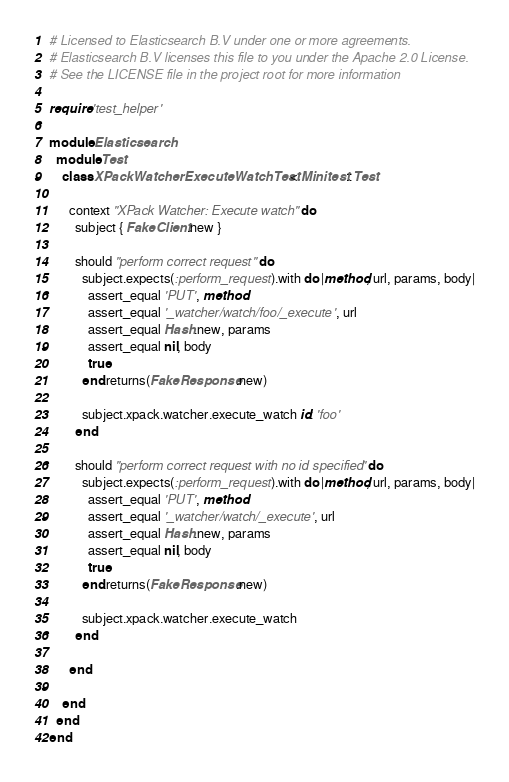<code> <loc_0><loc_0><loc_500><loc_500><_Ruby_># Licensed to Elasticsearch B.V under one or more agreements.
# Elasticsearch B.V licenses this file to you under the Apache 2.0 License.
# See the LICENSE file in the project root for more information

require 'test_helper'

module Elasticsearch
  module Test
    class XPackWatcherExecuteWatchTest < Minitest::Test

      context "XPack Watcher: Execute watch" do
        subject { FakeClient.new }

        should "perform correct request" do
          subject.expects(:perform_request).with do |method, url, params, body|
            assert_equal 'PUT', method
            assert_equal '_watcher/watch/foo/_execute', url
            assert_equal Hash.new, params
            assert_equal nil, body
            true
          end.returns(FakeResponse.new)

          subject.xpack.watcher.execute_watch id: 'foo'
        end

        should "perform correct request with no id specified" do
          subject.expects(:perform_request).with do |method, url, params, body|
            assert_equal 'PUT', method
            assert_equal '_watcher/watch/_execute', url
            assert_equal Hash.new, params
            assert_equal nil, body
            true
          end.returns(FakeResponse.new)

          subject.xpack.watcher.execute_watch
        end

      end

    end
  end
end
</code> 